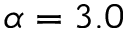<formula> <loc_0><loc_0><loc_500><loc_500>\alpha = 3 . 0</formula> 